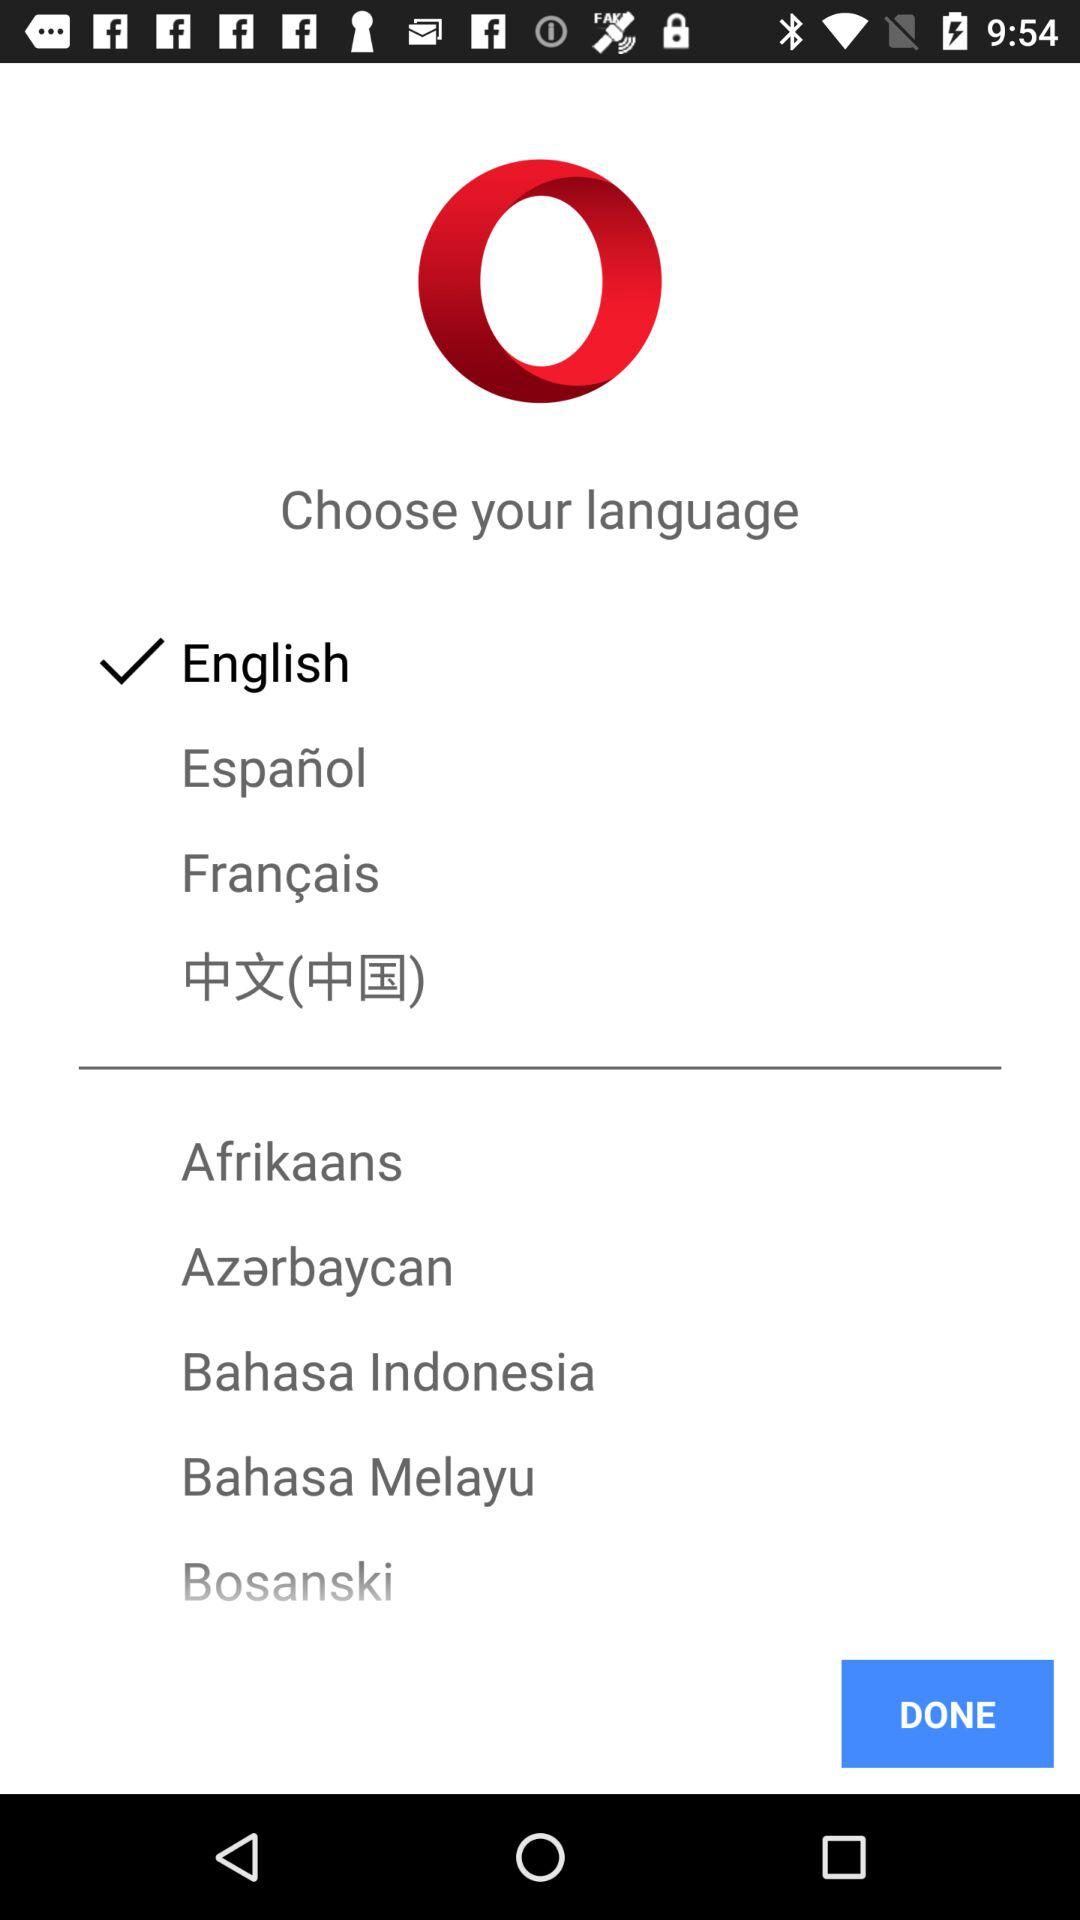How many languages are available to choose from?
Answer the question using a single word or phrase. 9 